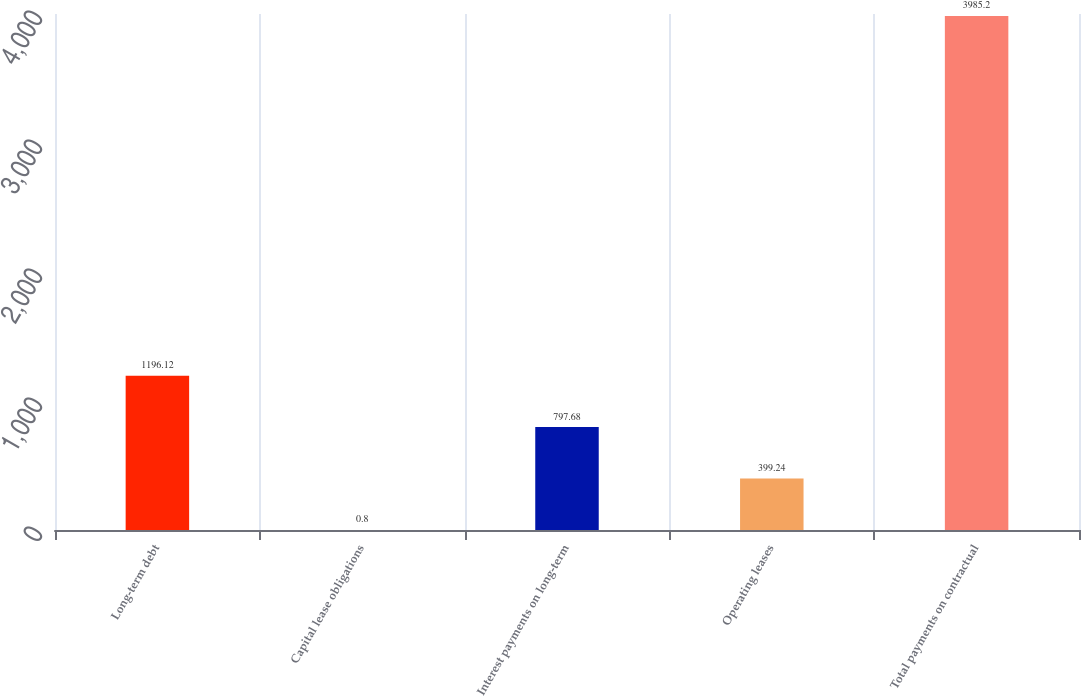Convert chart to OTSL. <chart><loc_0><loc_0><loc_500><loc_500><bar_chart><fcel>Long-term debt<fcel>Capital lease obligations<fcel>Interest payments on long-term<fcel>Operating leases<fcel>Total payments on contractual<nl><fcel>1196.12<fcel>0.8<fcel>797.68<fcel>399.24<fcel>3985.2<nl></chart> 